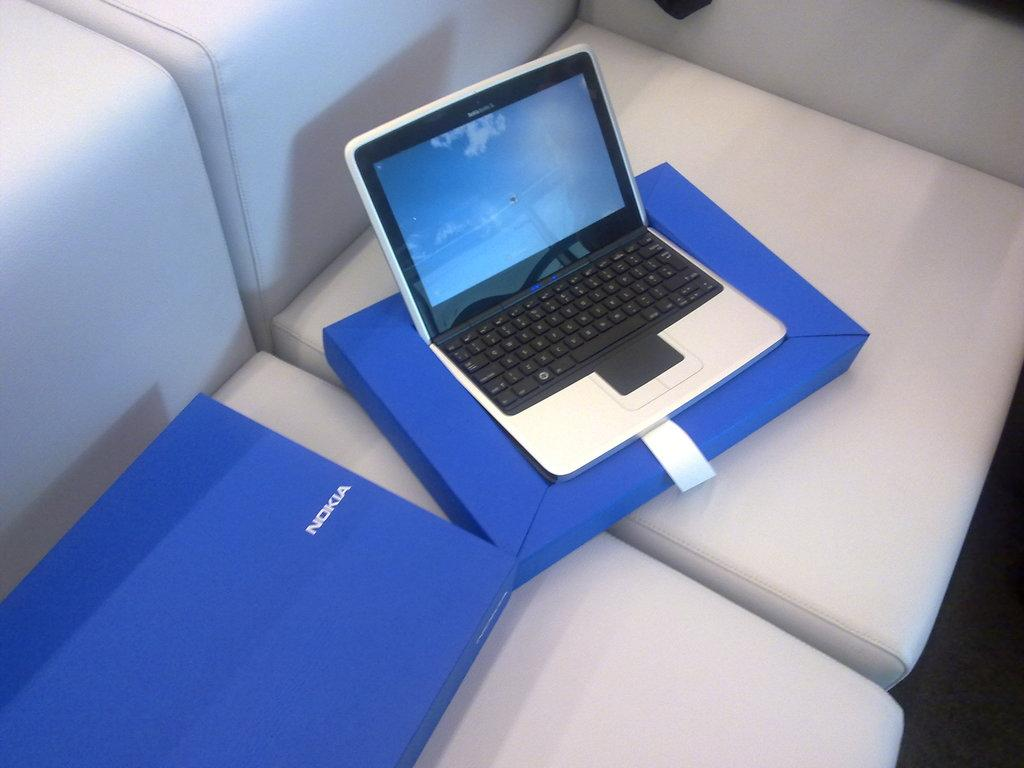<image>
Describe the image concisely. A laptop and two blue containers, one of which has nokia on it. 